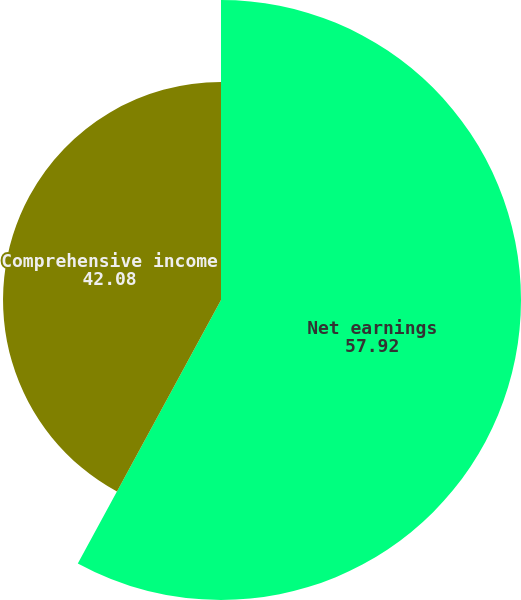Convert chart. <chart><loc_0><loc_0><loc_500><loc_500><pie_chart><fcel>Net earnings<fcel>Comprehensive income<nl><fcel>57.92%<fcel>42.08%<nl></chart> 